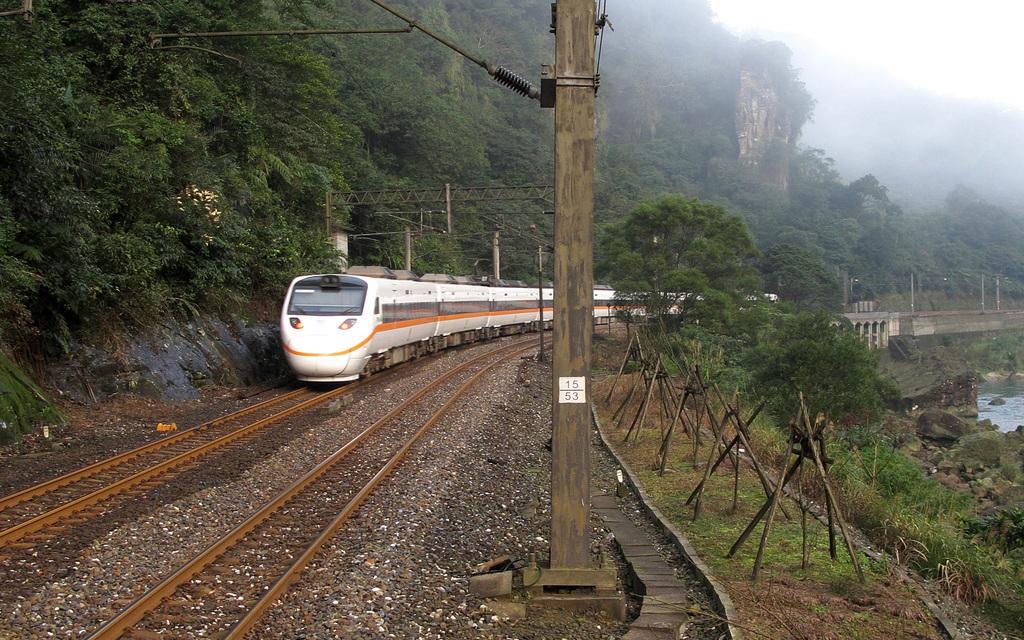How would you summarize this image in a sentence or two? In this image, we can see some trees and plants. There is a bridge on the right side of the image. There is a train and pole in the middle of the image. There are tracks in the bottom left of the image. There is a hill at the top of the image. 